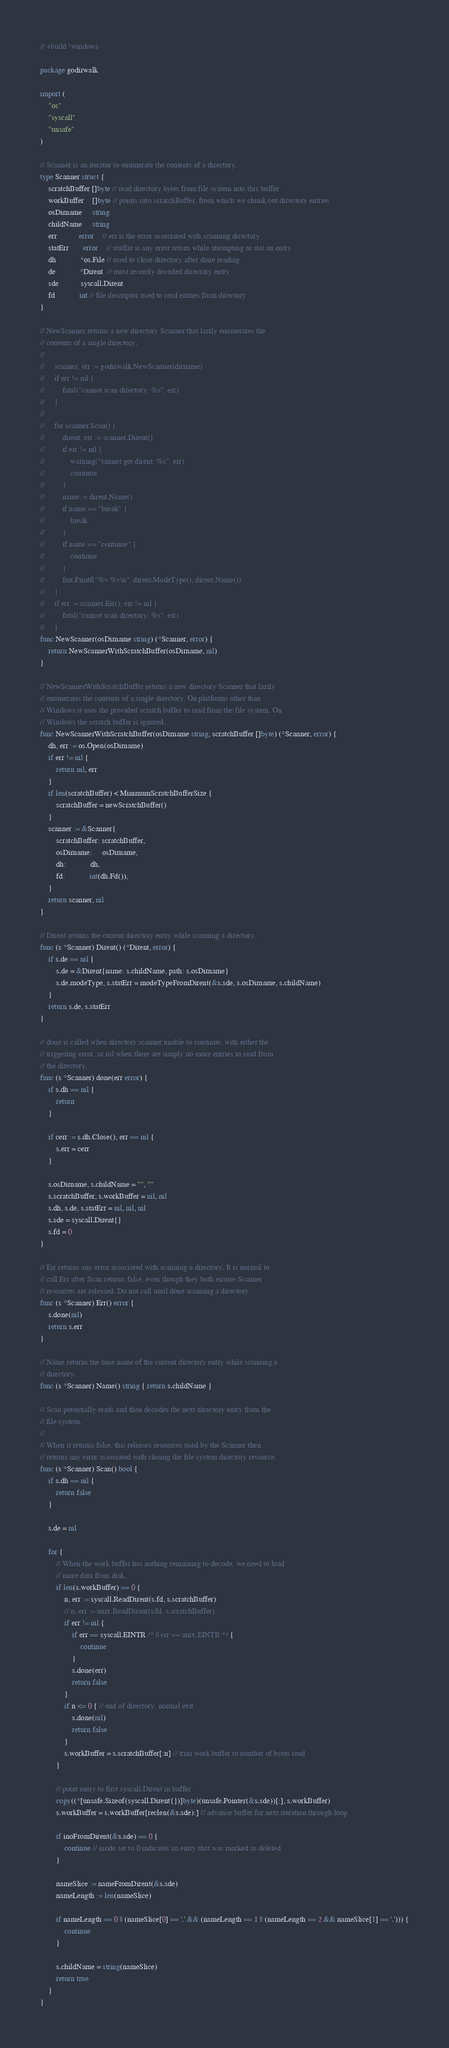Convert code to text. <code><loc_0><loc_0><loc_500><loc_500><_Go_>// +build !windows

package godirwalk

import (
	"os"
	"syscall"
	"unsafe"
)

// Scanner is an iterator to enumerate the contents of a directory.
type Scanner struct {
	scratchBuffer []byte // read directory bytes from file system into this buffer
	workBuffer    []byte // points into scratchBuffer, from which we chunk out directory entries
	osDirname     string
	childName     string
	err           error    // err is the error associated with scanning directory
	statErr       error    // statErr is any error return while attempting to stat an entry
	dh            *os.File // used to close directory after done reading
	de            *Dirent  // most recently decoded directory entry
	sde           syscall.Dirent
	fd            int // file descriptor used to read entries from directory
}

// NewScanner returns a new directory Scanner that lazily enumerates the
// contents of a single directory.
//
//     scanner, err := godirwalk.NewScanner(dirname)
//     if err != nil {
//         fatal("cannot scan directory: %s", err)
//     }
//
//     for scanner.Scan() {
//         dirent, err := scanner.Dirent()
//         if err != nil {
//             warning("cannot get dirent: %s", err)
//             continue
//         }
//         name := dirent.Name()
//         if name == "break" {
//             break
//         }
//         if name == "continue" {
//             continue
//         }
//         fmt.Printf("%v %v\n", dirent.ModeType(), dirent.Name())
//     }
//     if err := scanner.Err(); err != nil {
//         fatal("cannot scan directory: %s", err)
//     }
func NewScanner(osDirname string) (*Scanner, error) {
	return NewScannerWithScratchBuffer(osDirname, nil)
}

// NewScannerWithScratchBuffer returns a new directory Scanner that lazily
// enumerates the contents of a single directory. On platforms other than
// Windows it uses the provided scratch buffer to read from the file system. On
// Windows the scratch buffer is ignored.
func NewScannerWithScratchBuffer(osDirname string, scratchBuffer []byte) (*Scanner, error) {
	dh, err := os.Open(osDirname)
	if err != nil {
		return nil, err
	}
	if len(scratchBuffer) < MinimumScratchBufferSize {
		scratchBuffer = newScratchBuffer()
	}
	scanner := &Scanner{
		scratchBuffer: scratchBuffer,
		osDirname:     osDirname,
		dh:            dh,
		fd:            int(dh.Fd()),
	}
	return scanner, nil
}

// Dirent returns the current directory entry while scanning a directory.
func (s *Scanner) Dirent() (*Dirent, error) {
	if s.de == nil {
		s.de = &Dirent{name: s.childName, path: s.osDirname}
		s.de.modeType, s.statErr = modeTypeFromDirent(&s.sde, s.osDirname, s.childName)
	}
	return s.de, s.statErr
}

// done is called when directory scanner unable to continue, with either the
// triggering error, or nil when there are simply no more entries to read from
// the directory.
func (s *Scanner) done(err error) {
	if s.dh == nil {
		return
	}

	if cerr := s.dh.Close(); err == nil {
		s.err = cerr
	}

	s.osDirname, s.childName = "", ""
	s.scratchBuffer, s.workBuffer = nil, nil
	s.dh, s.de, s.statErr = nil, nil, nil
	s.sde = syscall.Dirent{}
	s.fd = 0
}

// Err returns any error associated with scanning a directory. It is normal to
// call Err after Scan returns false, even though they both ensure Scanner
// resources are released. Do not call until done scanning a directory.
func (s *Scanner) Err() error {
	s.done(nil)
	return s.err
}

// Name returns the base name of the current directory entry while scanning a
// directory.
func (s *Scanner) Name() string { return s.childName }

// Scan potentially reads and then decodes the next directory entry from the
// file system.
//
// When it returns false, this releases resources used by the Scanner then
// returns any error associated with closing the file system directory resource.
func (s *Scanner) Scan() bool {
	if s.dh == nil {
		return false
	}

	s.de = nil

	for {
		// When the work buffer has nothing remaining to decode, we need to load
		// more data from disk.
		if len(s.workBuffer) == 0 {
			n, err := syscall.ReadDirent(s.fd, s.scratchBuffer)
			// n, err := unix.ReadDirent(s.fd, s.scratchBuffer)
			if err != nil {
				if err == syscall.EINTR /* || err == unix.EINTR */ {
					continue
				}
				s.done(err)
				return false
			}
			if n <= 0 { // end of directory: normal exit
				s.done(nil)
				return false
			}
			s.workBuffer = s.scratchBuffer[:n] // trim work buffer to number of bytes read
		}

		// point entry to first syscall.Dirent in buffer
		copy((*[unsafe.Sizeof(syscall.Dirent{})]byte)(unsafe.Pointer(&s.sde))[:], s.workBuffer)
		s.workBuffer = s.workBuffer[reclen(&s.sde):] // advance buffer for next iteration through loop

		if inoFromDirent(&s.sde) == 0 {
			continue // inode set to 0 indicates an entry that was marked as deleted
		}

		nameSlice := nameFromDirent(&s.sde)
		nameLength := len(nameSlice)

		if nameLength == 0 || (nameSlice[0] == '.' && (nameLength == 1 || (nameLength == 2 && nameSlice[1] == '.'))) {
			continue
		}

		s.childName = string(nameSlice)
		return true
	}
}
</code> 